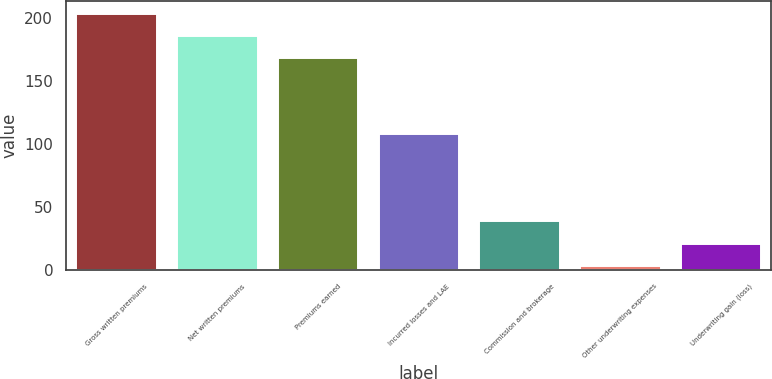<chart> <loc_0><loc_0><loc_500><loc_500><bar_chart><fcel>Gross written premiums<fcel>Net written premiums<fcel>Premiums earned<fcel>Incurred losses and LAE<fcel>Commission and brokerage<fcel>Other underwriting expenses<fcel>Underwriting gain (loss)<nl><fcel>203.4<fcel>185.75<fcel>168.1<fcel>108.4<fcel>38.6<fcel>3.3<fcel>20.95<nl></chart> 